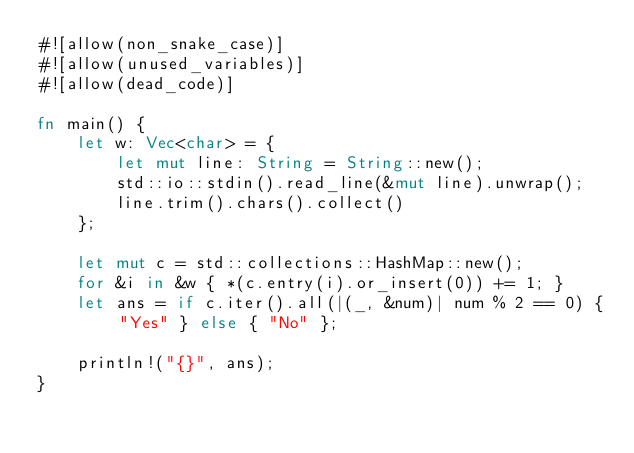<code> <loc_0><loc_0><loc_500><loc_500><_Rust_>#![allow(non_snake_case)]
#![allow(unused_variables)]
#![allow(dead_code)]

fn main() {
    let w: Vec<char> = {
        let mut line: String = String::new();
        std::io::stdin().read_line(&mut line).unwrap();
        line.trim().chars().collect()
    };

    let mut c = std::collections::HashMap::new();
    for &i in &w { *(c.entry(i).or_insert(0)) += 1; }
    let ans = if c.iter().all(|(_, &num)| num % 2 == 0) { "Yes" } else { "No" };

    println!("{}", ans);
}</code> 